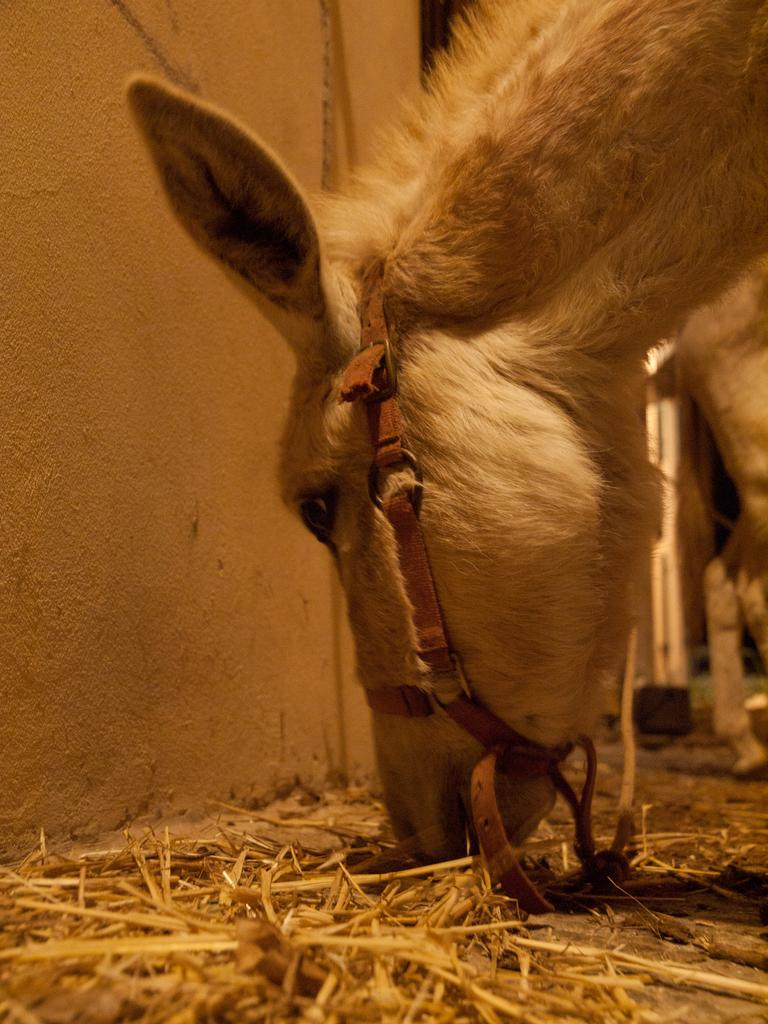What animal can be seen in the image? There is a horse in the image. What is the horse doing in the image? The horse is eating grass. What type of vegetation is visible at the bottom of the image? There is grass at the bottom of the image. What can be seen in the background of the image? There is a wall and some objects in the background of the image. What type of advertisement can be seen on the horse's back in the image? There is no advertisement present on the horse's back in the image. What type of iron object is being used by the horse in the image? There is no iron object present in the image, and the horse is not using any object. 